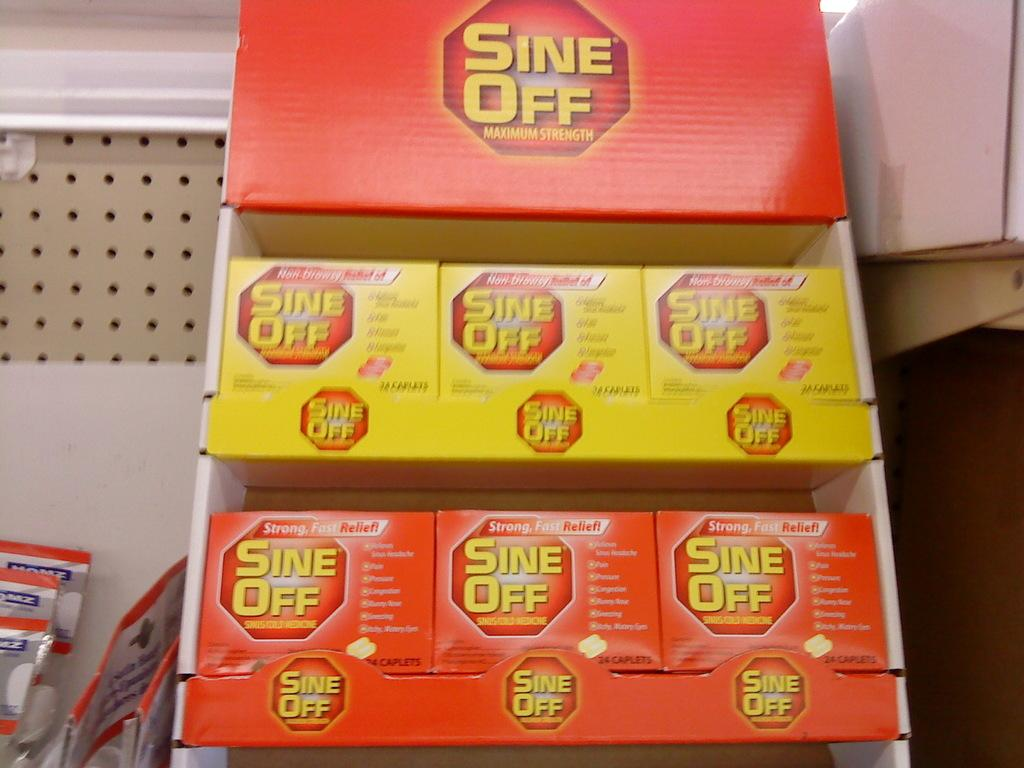<image>
Provide a brief description of the given image. a box of the brand called sine off maximum strength 